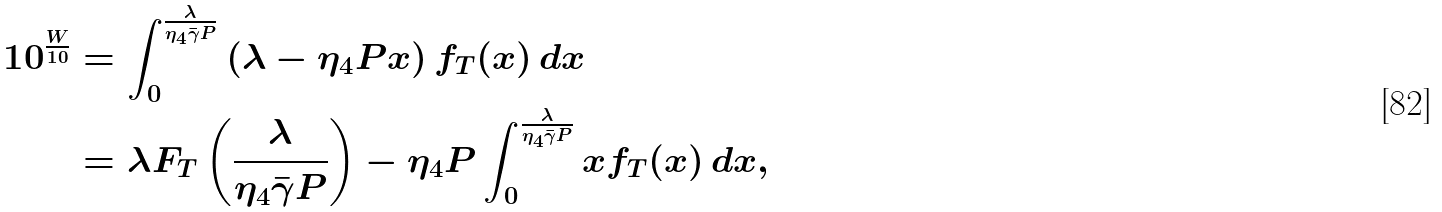Convert formula to latex. <formula><loc_0><loc_0><loc_500><loc_500>1 0 ^ { \frac { W } { 1 0 } } & = \int _ { 0 } ^ { \frac { \lambda } { \eta _ { 4 } \bar { \gamma } P } } \left ( \lambda - { \eta _ { 4 } } P x \right ) f _ { T } ( x ) \, d x \\ & = \lambda F _ { T } \left ( \frac { \lambda } { \eta _ { 4 } \bar { \gamma } P } \right ) - { \eta _ { 4 } } P \int _ { 0 } ^ { \frac { \lambda } { \eta _ { 4 } \bar { \gamma } P } } x f _ { T } ( x ) \, d x ,</formula> 